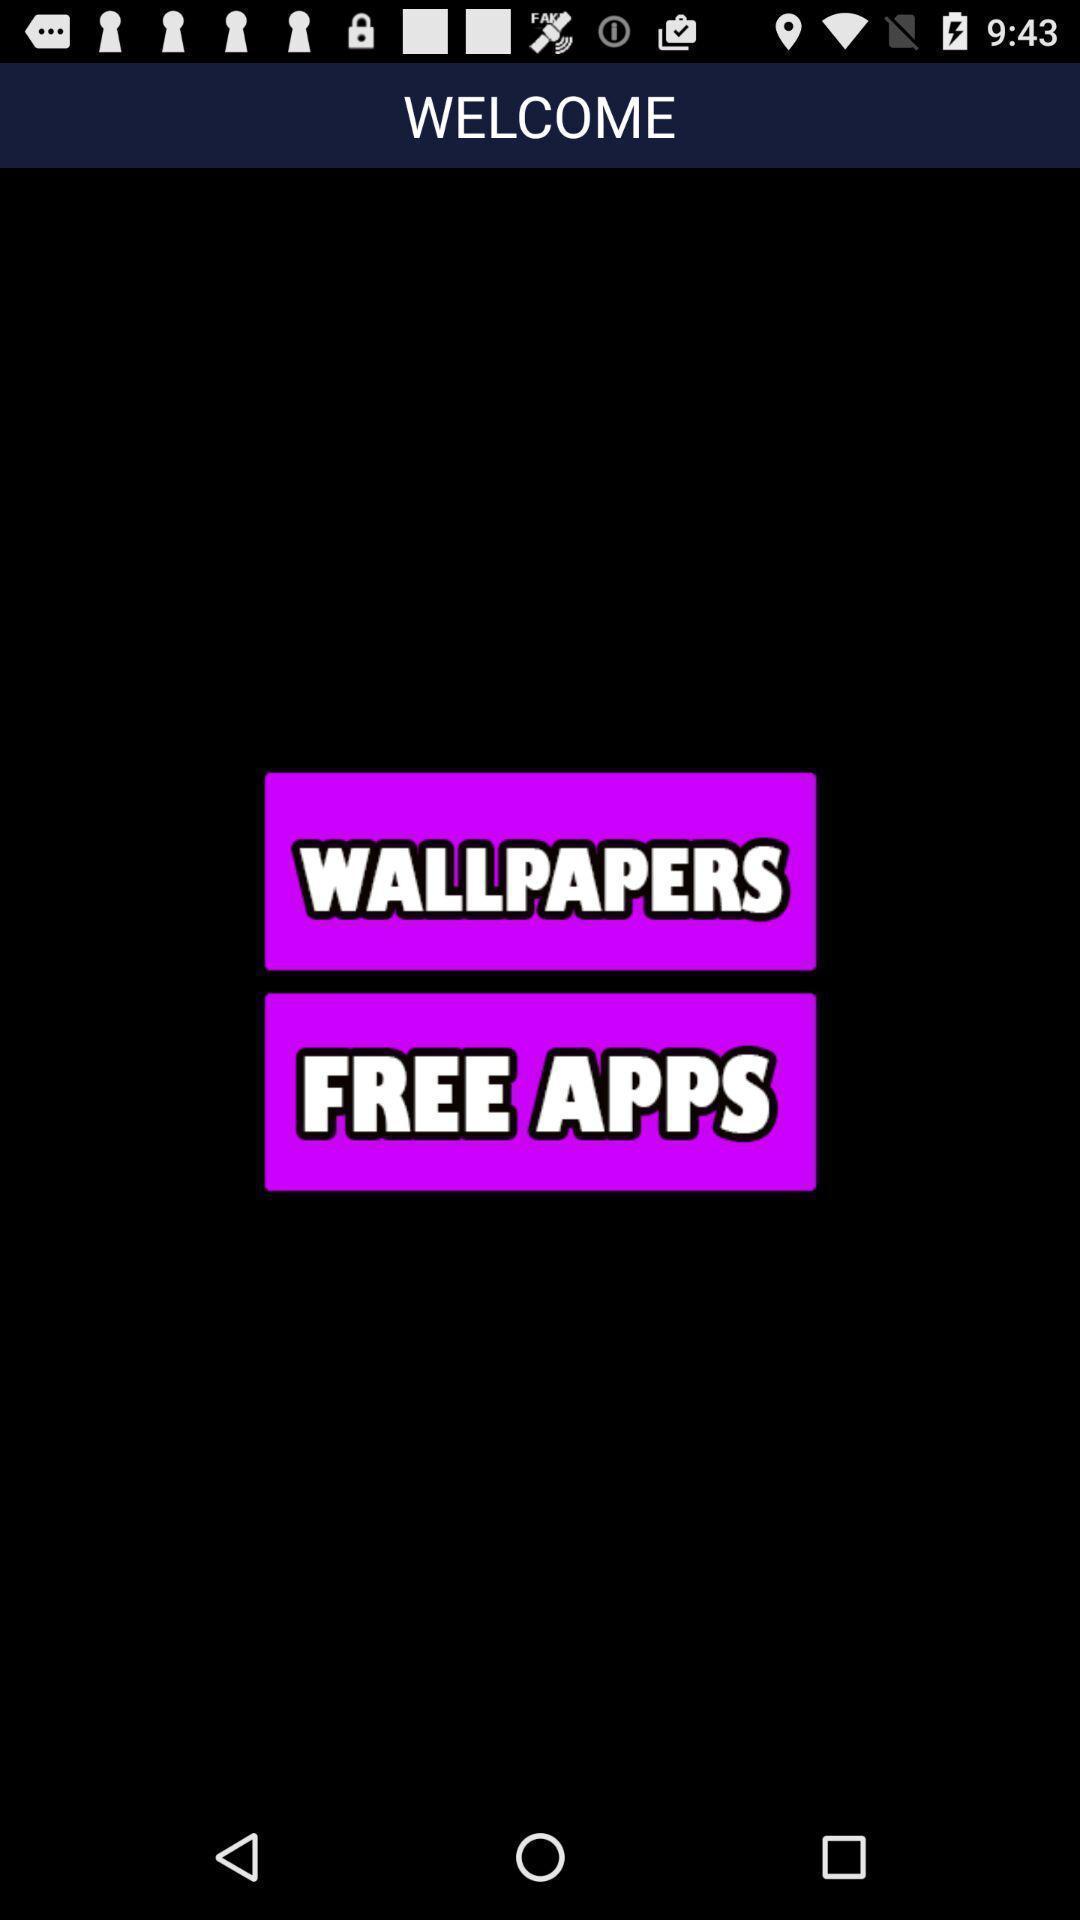Give me a narrative description of this picture. Welcome page. 